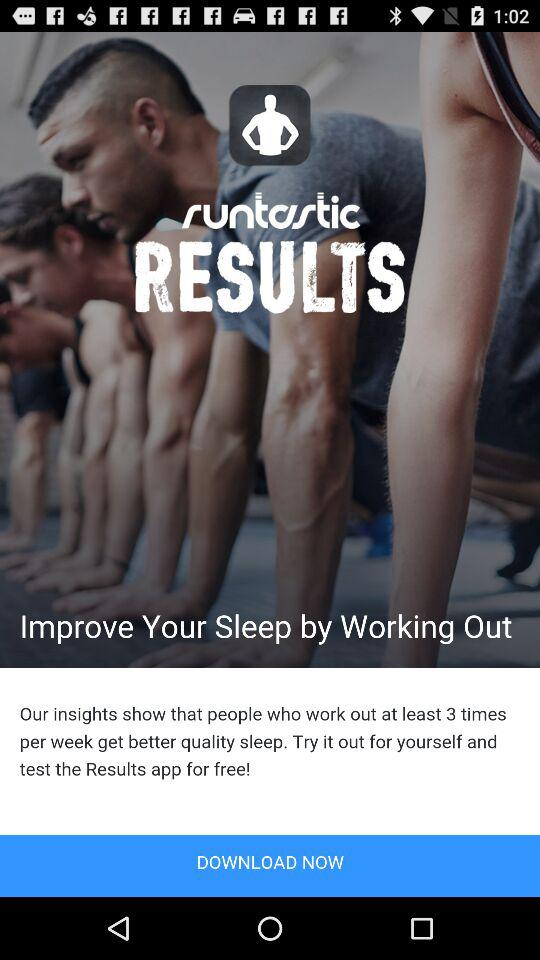What is the application name? The application name is "runtastic RESULTS". 